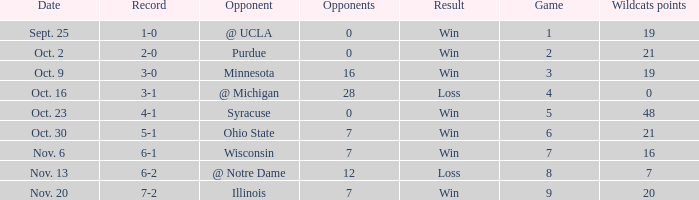What game number did the Wildcats play Purdue? 2.0. 